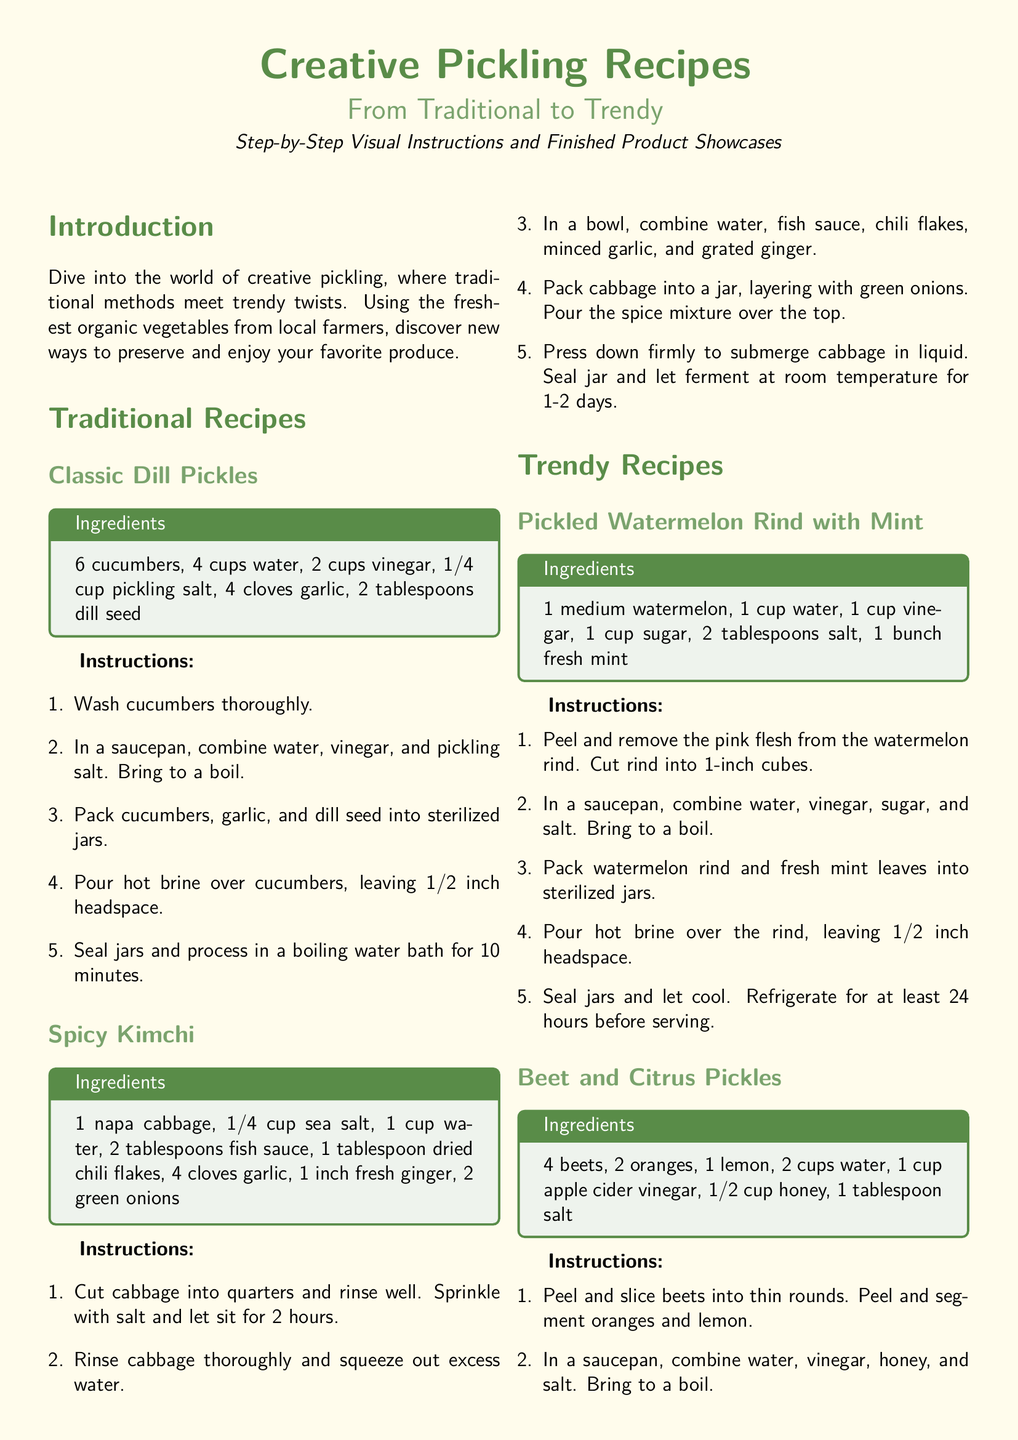What is the main theme of the document? The main theme is about exploring creative pickling recipes that range from traditional to trendy.
Answer: Creative pickling recipes How many cucumbers are required for the Classic Dill Pickles? The ingredient list specifies 6 cucumbers for the Classic Dill Pickles.
Answer: 6 cucumbers What is the total boiling time for processing Classic Dill Pickles? The instructions state that jars should be processed in a boiling water bath for 10 minutes.
Answer: 10 minutes Which vegetable is used in the Spicy Kimchi recipe? The main vegetable in the Spicy Kimchi recipe is napa cabbage.
Answer: Napa cabbage How long should the Pickled Watermelon Rind be refrigerated before serving? The instructions indicate to refrigerate for at least 24 hours before serving.
Answer: 24 hours What is one key tip for successful pickling mentioned in the document? One tip emphasizes the importance of using fresh, organic vegetables for the best flavor and texture.
Answer: Fresh, organic vegetables How many total recipes are presented in the document? There are four recipes presented: two traditional and two trendy.
Answer: Four recipes What ingredient is unique to the Beet and Citrus Pickles compared to other recipes? The inclusion of citrus fruits is unique to the Beet and Citrus Pickles recipe.
Answer: Citrus fruits What is the purpose of sterilizing jars and lids? Sterilizing jars and lids is essential to prevent contamination and ensure a longer shelf life.
Answer: Prevent contamination 